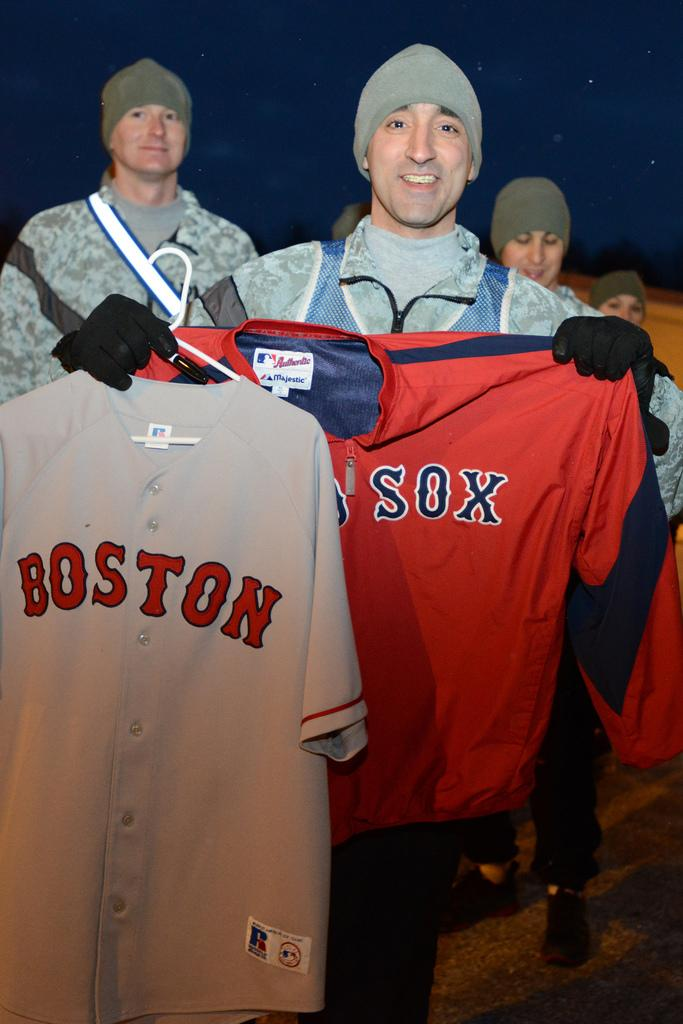<image>
Give a short and clear explanation of the subsequent image. A man holds two Boston Red Sox shirts up to the camera. 